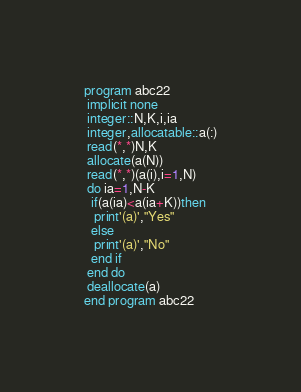<code> <loc_0><loc_0><loc_500><loc_500><_FORTRAN_>program abc22
 implicit none
 integer::N,K,i,ia
 integer,allocatable::a(:)
 read(*,*)N,K
 allocate(a(N))
 read(*,*)(a(i),i=1,N)
 do ia=1,N-K
  if(a(ia)<a(ia+K))then
   print'(a)',"Yes"
  else
   print'(a)',"No"
  end if
 end do
 deallocate(a)
end program abc22</code> 